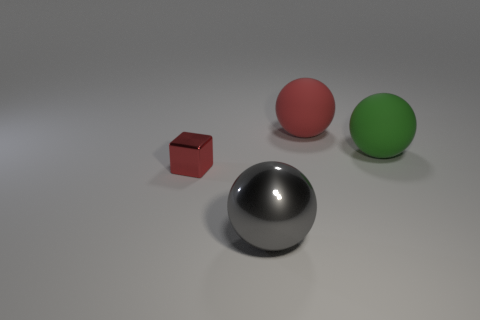Are there any other things that are the same size as the red block?
Offer a very short reply. No. There is a red object that is the same shape as the green rubber object; what material is it?
Provide a succinct answer. Rubber. How big is the matte ball right of the red object that is right of the large gray metallic thing?
Provide a succinct answer. Large. Are any small objects visible?
Provide a short and direct response. Yes. There is a big thing that is left of the green rubber thing and behind the small metal thing; what is its material?
Make the answer very short. Rubber. Are there more small metallic things that are right of the gray object than gray metallic balls that are to the left of the small thing?
Ensure brevity in your answer.  No. Are there any yellow things that have the same size as the red rubber sphere?
Offer a terse response. No. There is a red thing right of the object in front of the object to the left of the gray metallic ball; what is its size?
Provide a succinct answer. Large. The small thing has what color?
Offer a very short reply. Red. Is the number of small red cubes that are behind the metallic block greater than the number of blocks?
Offer a very short reply. No. 